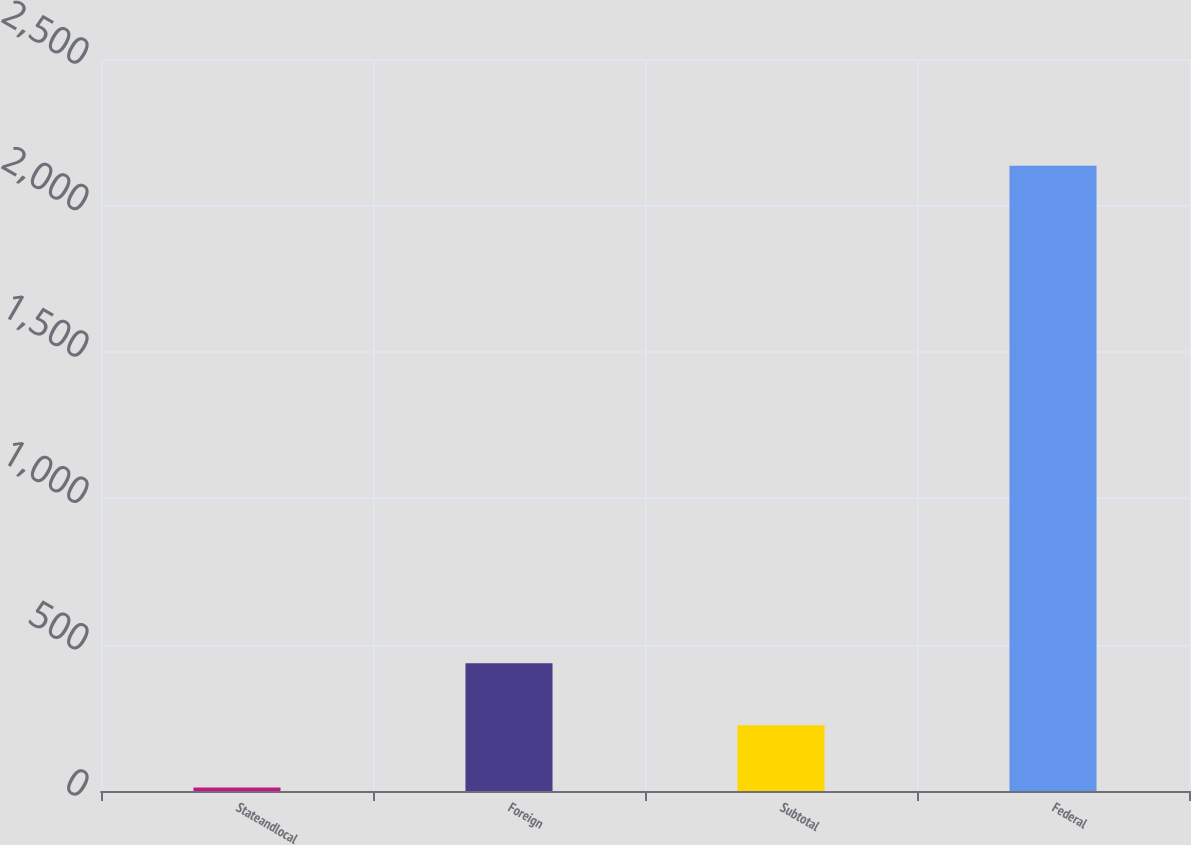Convert chart to OTSL. <chart><loc_0><loc_0><loc_500><loc_500><bar_chart><fcel>Stateandlocal<fcel>Foreign<fcel>Subtotal<fcel>Federal<nl><fcel>12<fcel>436.6<fcel>224.3<fcel>2135<nl></chart> 